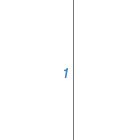<code> <loc_0><loc_0><loc_500><loc_500><_CSS_>
</code> 